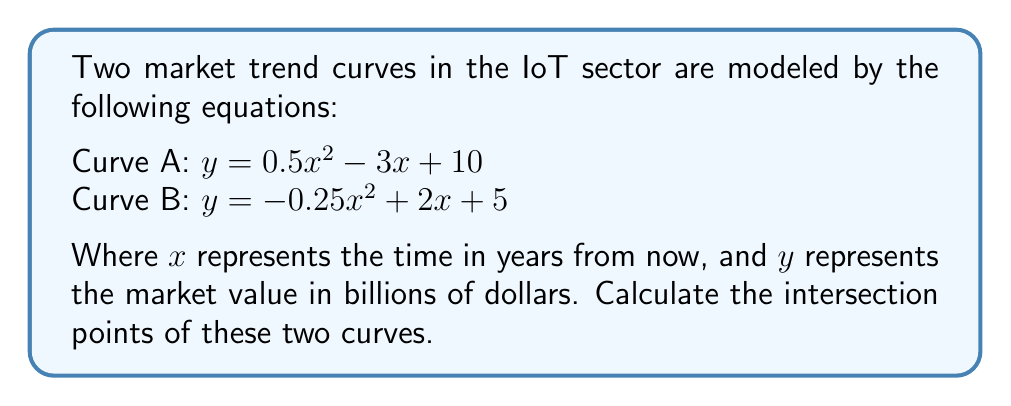Teach me how to tackle this problem. To find the intersection points, we need to solve the equation where both curves have the same y-value:

1) Set the equations equal to each other:
   $0.5x^2 - 3x + 10 = -0.25x^2 + 2x + 5$

2) Rearrange the equation to standard form:
   $0.5x^2 - 3x + 10 + 0.25x^2 - 2x - 5 = 0$
   $0.75x^2 - 5x + 5 = 0$

3) Multiply all terms by 4 to simplify the coefficients:
   $3x^2 - 20x + 20 = 0$

4) This is a quadratic equation. We can solve it using the quadratic formula:
   $x = \frac{-b \pm \sqrt{b^2 - 4ac}}{2a}$

   Where $a = 3$, $b = -20$, and $c = 20$

5) Substituting these values:
   $x = \frac{20 \pm \sqrt{(-20)^2 - 4(3)(20)}}{2(3)}$
   $x = \frac{20 \pm \sqrt{400 - 240}}{6}$
   $x = \frac{20 \pm \sqrt{160}}{6}$
   $x = \frac{20 \pm 4\sqrt{10}}{6}$

6) Simplifying:
   $x_1 = \frac{20 + 4\sqrt{10}}{6} \approx 5.11$
   $x_2 = \frac{20 - 4\sqrt{10}}{6} \approx 1.56$

7) To find the y-coordinates, substitute either x-value into one of the original equations:
   For $x_1$: $y = 0.5(5.11)^2 - 3(5.11) + 10 \approx 10.28$
   For $x_2$: $y = 0.5(1.56)^2 - 3(1.56) + 10 \approx 6.82$

Therefore, the intersection points are approximately (1.56, 6.82) and (5.11, 10.28).
Answer: (1.56, 6.82) and (5.11, 10.28) 